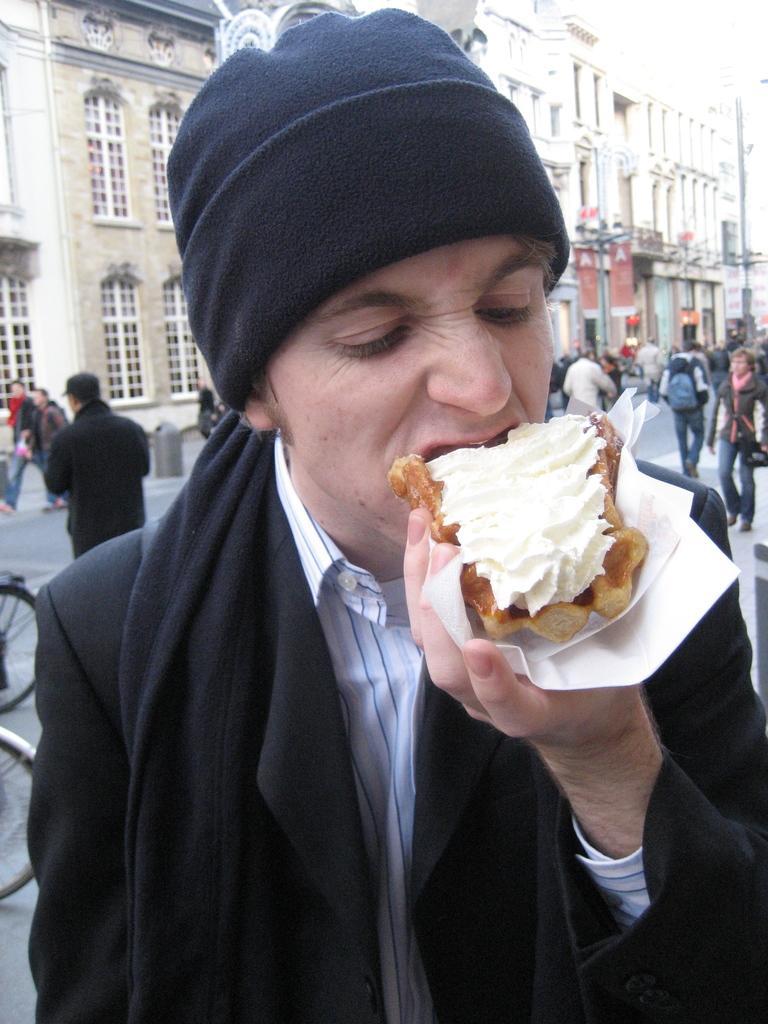Could you give a brief overview of what you see in this image? In this image there is a man standing towards the bottom of the image, he is holding an object, there are a group of persons walking on the road, there are bicycle wheels towards the left of the image, there is a pole, there are buildings, there are windows. 